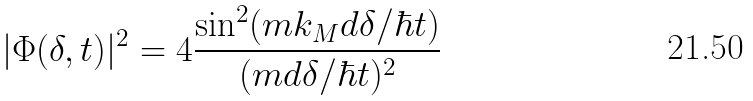<formula> <loc_0><loc_0><loc_500><loc_500>| \Phi ( \delta , t ) | ^ { 2 } = 4 \frac { \sin ^ { 2 } ( m k _ { M } d \delta / \hbar { t } ) } { ( m d \delta / \hbar { t } ) ^ { 2 } }</formula> 